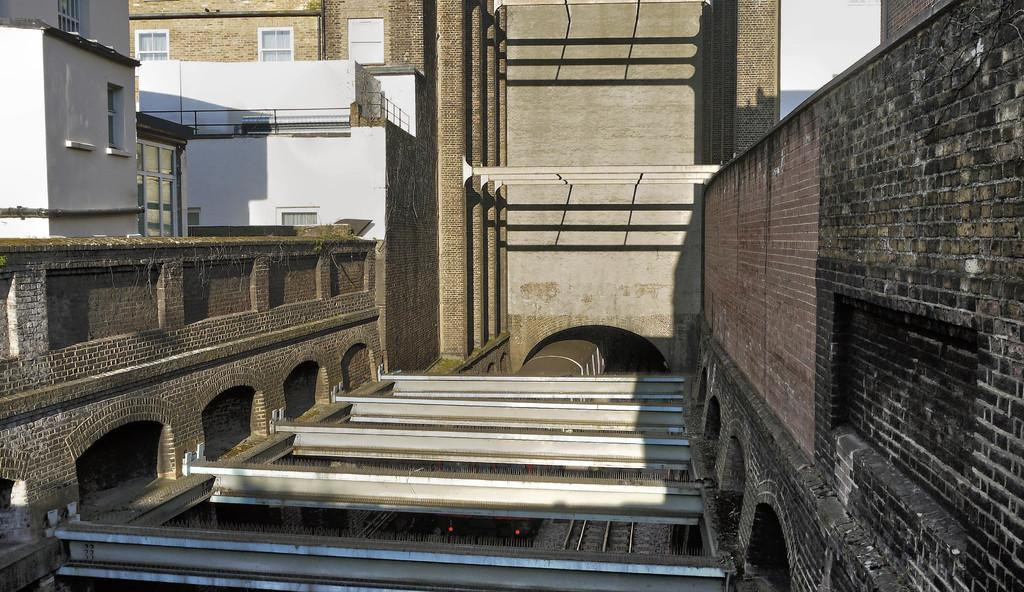What type of structures can be seen in the image? There are buildings in the image. What feature is present in the image that allows for transportation? There is a tunnel in the image. What is passing through the tunnel in the image? A train is passing through the tunnel in the image. What season is depicted in the image? The provided facts do not mention any season, so it cannot be determined from the image. How many children are visible in the image? There are no children present in the image. 